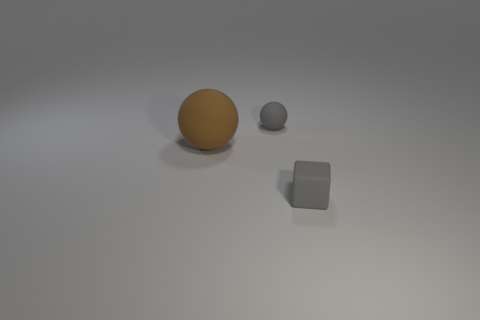Can you describe the lighting in the scene? The image features soft lighting that creates a diffuse shadow beneath each object, suggesting an evenly spread light source, possibly from above. 